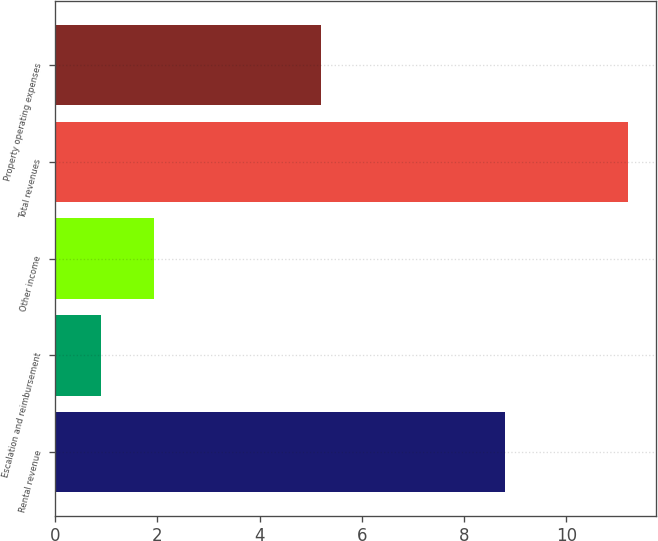Convert chart. <chart><loc_0><loc_0><loc_500><loc_500><bar_chart><fcel>Rental revenue<fcel>Escalation and reimbursement<fcel>Other income<fcel>Total revenues<fcel>Property operating expenses<nl><fcel>8.8<fcel>0.9<fcel>1.93<fcel>11.2<fcel>5.2<nl></chart> 